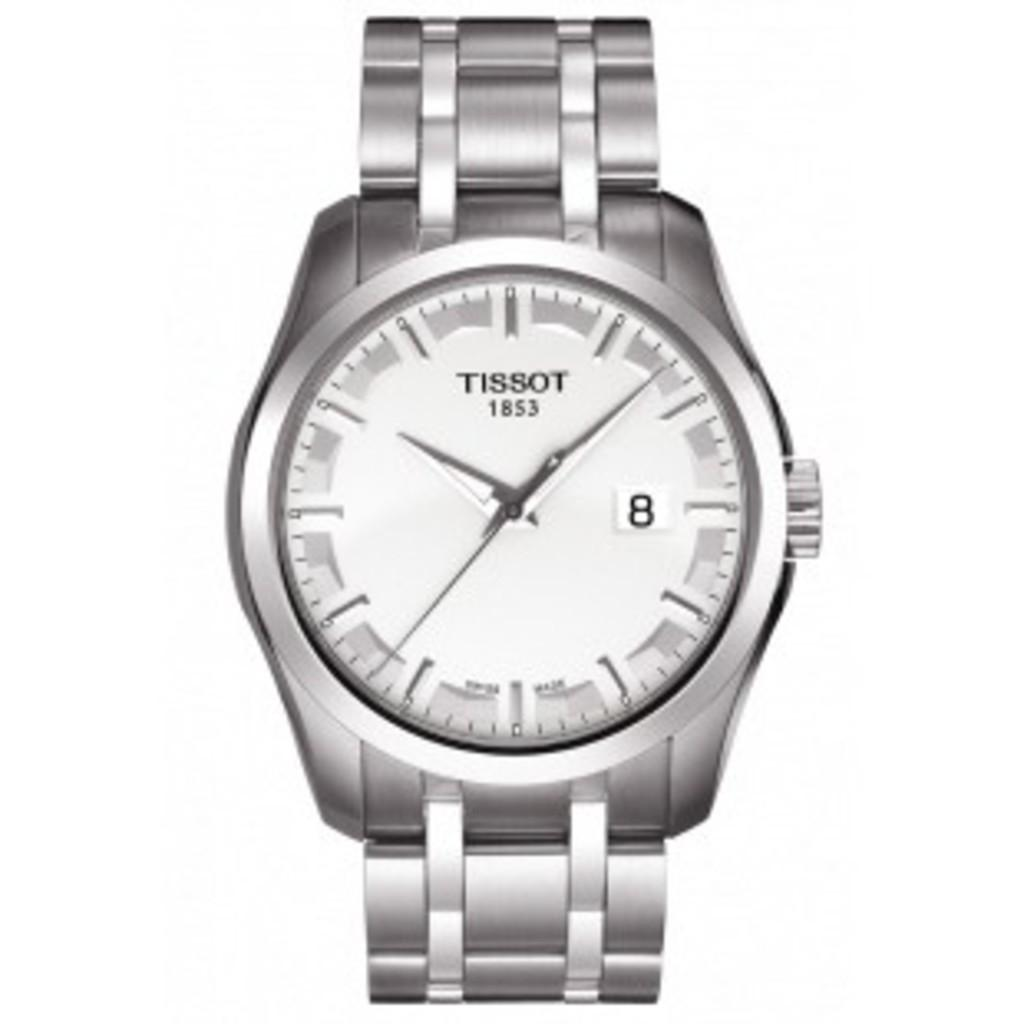<image>
Create a compact narrative representing the image presented. A silver Tissot watch with the number 8 on it. 